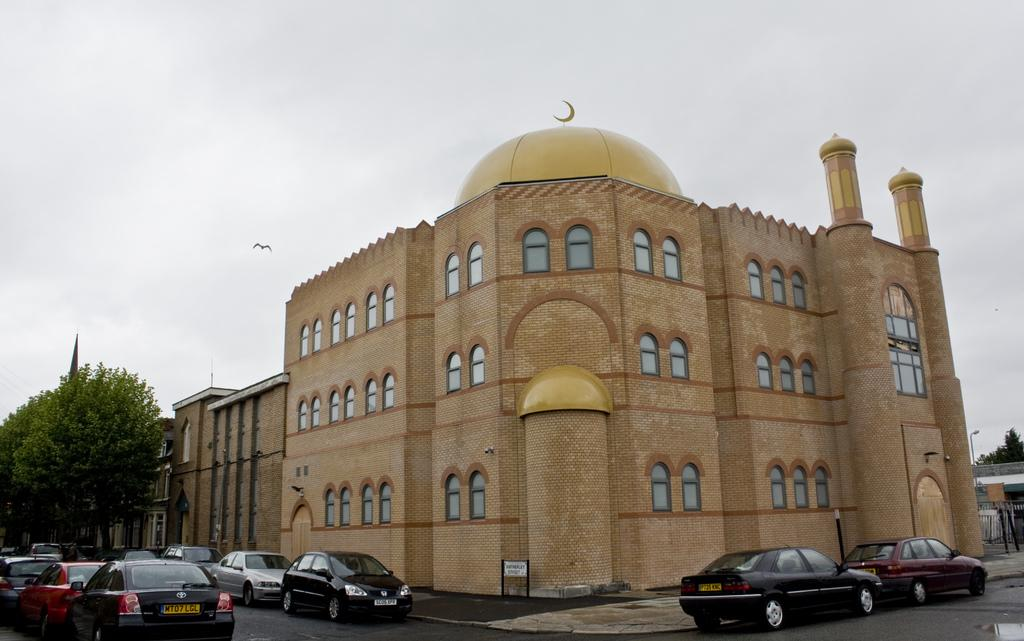What type of structures can be seen in the image? There are buildings in the image. What other natural or man-made elements can be seen in the image? There are trees, poles, vehicles, a road, a board, and the sky visible in the image. Can you describe the vehicles in the image? Vehicles are on the road in the image. What is happening in the sky in the image? A bird is flying in the air. How many steps are visible in the image? There are no steps visible in the image. What type of pipe can be seen in the image? There is no pipe present in the image. 